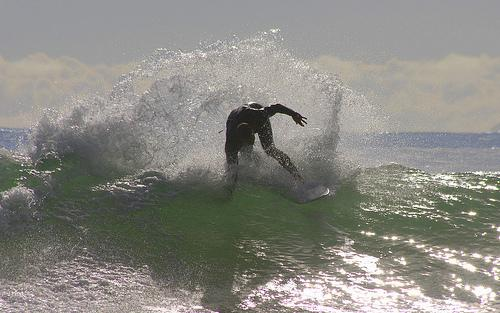Describe the scene involving the person wearing a black wetsuit. A surfer in a black wetsuit is riding a wave on a white surfboard, crouching and extending their left hand for balance amid very choppy ocean waters. What kind of physical posture can be seen from the surfer in the image? The surfer in the image is in a crouched or bent over position, with one hand extended and another hand down in the water to help maintain balance. Identify the colors and main elements of the ocean waters depicted in the picture. The ocean water is a mix of green and blue hues, characterized by very choppy waves with white crests, and the surfer interacting with the waves. Explain the appearance of sunlight in the image. Sunlight is reflecting off the choppy ocean water, creating a beautiful and vibrant scene, as well as producing shadow effects for the surfer and the surrounding area. How would you describe the water condition in the image? The water in the image is very choppy with large waves rolling in, creating splashes and leading to dramatic interactions between the surfer and the water. Assess the quality of the image in terms of the details captured. The image quality is very good, capturing a variety of details such as the surfer's posture, wave conditions, sunlight reflections, shadows, and a vivid blue sky with clouds. Determine the sentiment or mood evoked by the image. The image evokes a sense of excitement, adventure, and beauty, as the surfer tackles the large, choppy ocean waves under a blue and white sky. Count the number of clouds in the sky and describe their appearance. There are three separate sets of clouds in the sky, all appearing white and fluffy, with various sizes and shapes. What color is the sky in the image? The sky in the image is blue and white due to the presence of white fluffy clouds. Analyze the interaction between the surfer and the wave in the image. The surfer is skillfully riding the wave, crouching for stability, and using their hands to maintain balance in the midst of the challenging and choppy conditions. Describe the sentiment in this image with a surfer on a wave. The image evokes a sense of adventure, excitement, and freedom. Identify the attributes of the surfboard in the image. The surfboard is white, has a tip, and measures 99x99 in size. Notice the group of seagulls flying just above the ocean waves on the right-hand side, creating a beautiful scene. How many seagulls do you see in the image? The instruction suggests the presence of seagulls in the image, but there are none. By mentioning a specific area (right-hand side) and framing it as a beautiful scene, the instruction attempts to persuade the reader to search for the non-existent birds. Choose the correct description of the surfer's position: (a) lying down (b) standing up (c) crouched c) crouched Given a region X:201, Y:170, Width:43, and Height:43, what object is present in this area? A person's hand in the water Identify the shark fin poking out of the water near the bottom-left part of the image, just a few feet away from the surfer. This instruction attempts to suggest a sense of danger by mentioning a shark fin that is not present in the image. The specific location (bottom-left) and proximity to the surfer make it sound more convincing. What is the surfer doing in the water? The surfer is riding a wave on a surfboard, balancing with one hand up and the other down in the water. What color is the surfer's wetsuit? Black Provide a caption for an image of an ocean landscape with a surfer on a surfboard. A surfer on a white surfboard riding a choppy wave in an ocean landscape with blue and white sky. The lighthouse in the distance, positioned between two of the larger waves, is quite a striking image. What color is it? The instruction implies the presence of a lighthouse that does not exist in the image. By asking about color and giving a vague but suggestive placement ("between two of the larger waves"), it encourages the reader to search for the nonexistent object. Provide the semantic segmentation of the person on the surfboard. The person on the surfboard has dark brown hair, left hand extended, and wears a black wetsuit and measures 125x125 in size. Locate any anomalies in the image of a surfer riding a wave. There are no major anomalies in the image. What does the reflection on the ocean water look like? The sunlight reflection on the ocean water appears bright and covers an area measuring 62x62 in size. Can you spot the smiling dolphin swimming near the surfer? It should be right in the middle of the image. There is no dolphin present in the image, but the instruction is designed to make the reader search for a non-existent object by giving a specific location ("right in the middle") to look for it. What is the most predominant color in the sky? Blue Where can the white fluffy clouds in the sky be located in the image? The white fluffy clouds can be located at X:398, Y:28 with Width:100 and Height:100. Rate the image quality for a picture of a surfer riding a wave. The image quality is high and provides clear details of the surfer and the wave. Is there any anomaly in the surfer's position or posture? No, there are no anomalies in the surfer's position or posture. How would you describe the water in the image? The water is choppy, with waves splashing and sunlight reflecting off of it. Detect any text present in the image of a surfer on a wave. There is no text present in the image. Explain how the surfer on the surfboard is interacting with the ocean waves. The surfer is skillfully riding the wave and maintaining balance as the choppy water surrounds them. What is the color of the sailboat in the upper-left corner of the image? It really stands out against the blue and white sky. The instruction invites the reader to consider the color of an object (sailboat) that is not present in the image. By mentioning the contrasting sky colors, the instruction makes the reader think it should be easier to find the nonexistent object. Are there any clouds in the sky? If yes, what color are they? Yes, there are white clouds in the sky. Ground the expression "water rise over surfer" in the image. Water rise over surfer refers to the area with coordinates X:99, Y:22, Width:277, and Height:277. Identify the objects in the image and their sizes. Ocean landscape (411x411), person in black wetsuit (95x95), person on surfboard (167x167), choppy water (103x103), person with brown hair (101x101), white clouds (100x100), white surfboard (106x106) Locate the bright red starfish in the bottom-right corner of the photograph, sitting on a rock. This instruction suggests that there is a starfish on a rock in the scene, but there is no starfish or even a mention of a rock as an existing object in the given information. 